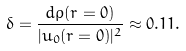Convert formula to latex. <formula><loc_0><loc_0><loc_500><loc_500>\delta = \frac { d \rho ( r = 0 ) } { | u _ { 0 } ( r = 0 ) | ^ { 2 } } \approx 0 . 1 1 .</formula> 